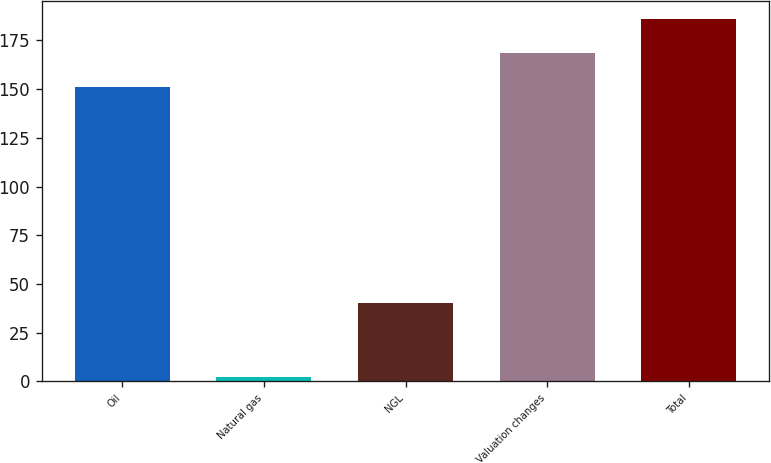Convert chart. <chart><loc_0><loc_0><loc_500><loc_500><bar_chart><fcel>Oil<fcel>Natural gas<fcel>NGL<fcel>Valuation changes<fcel>Total<nl><fcel>151<fcel>2.45<fcel>40<fcel>168.56<fcel>186.12<nl></chart> 